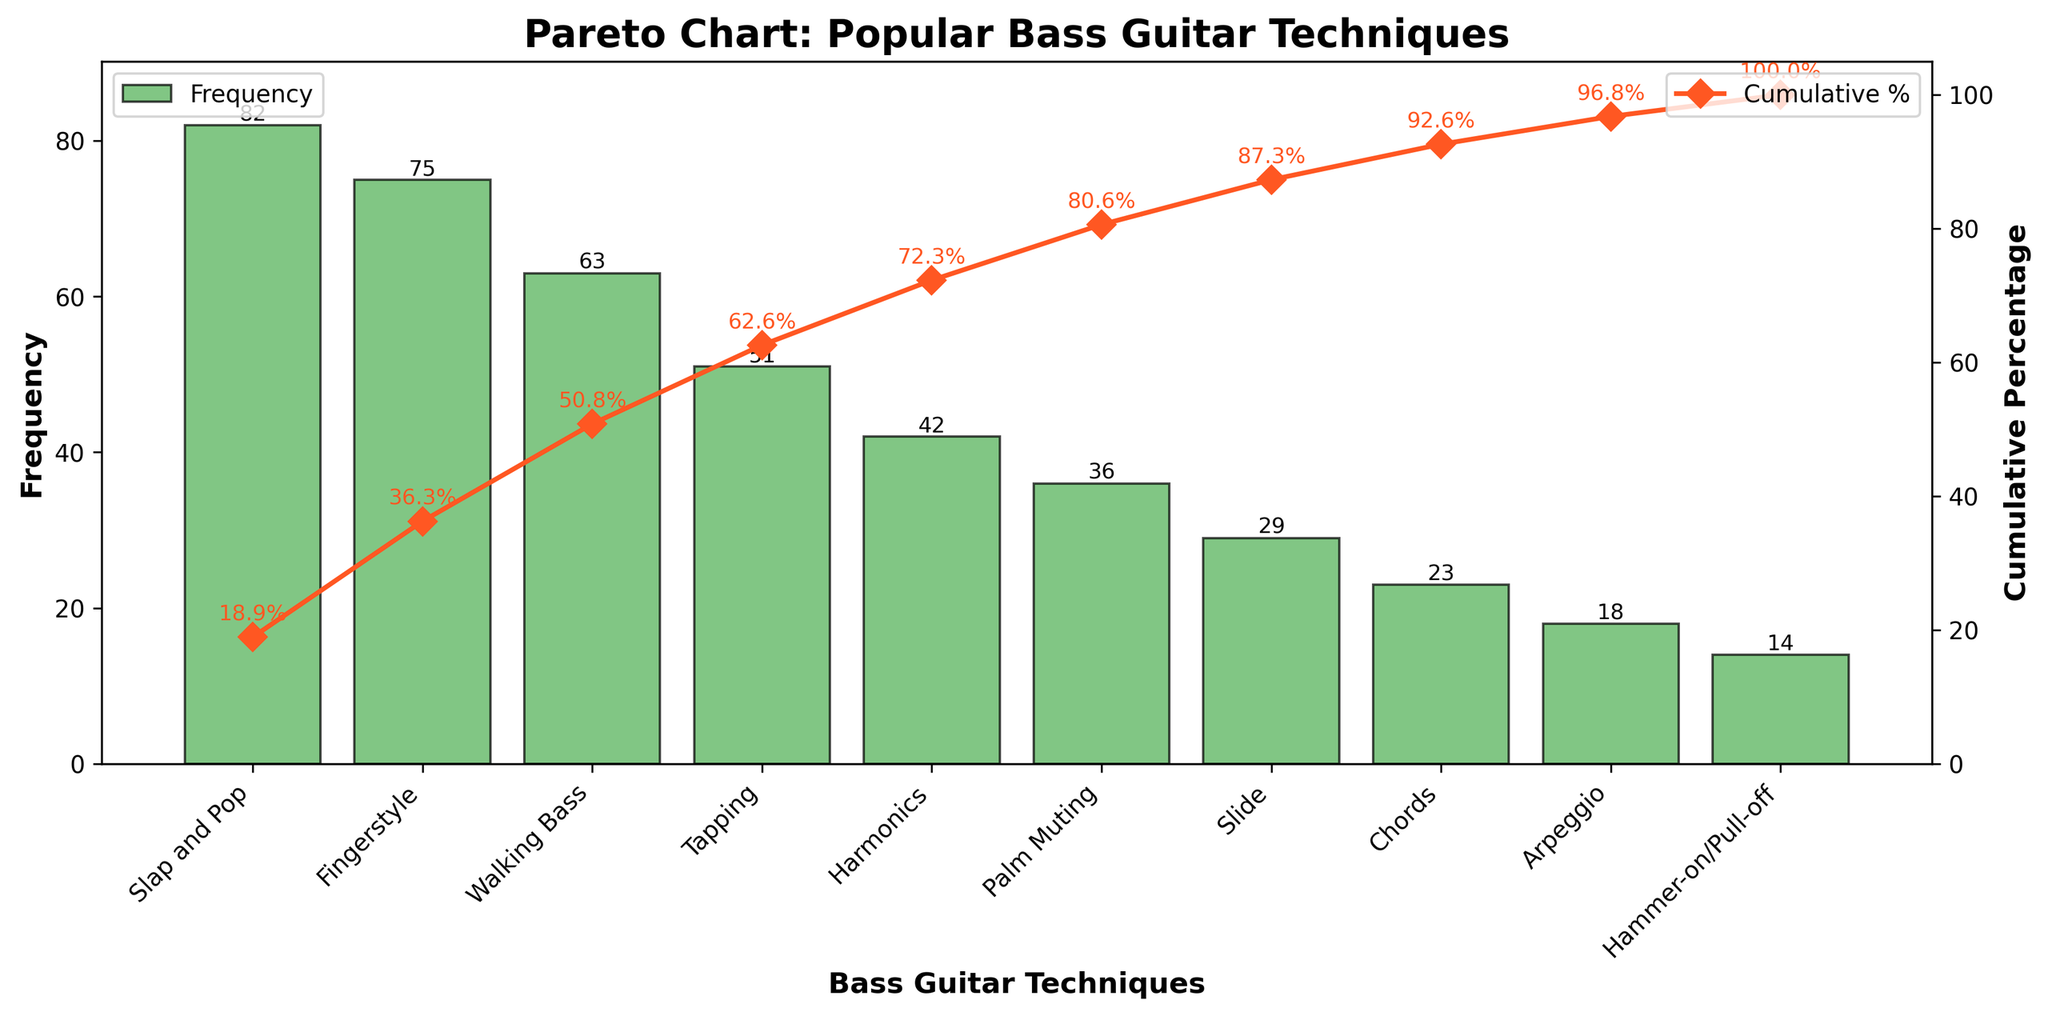How many bass guitar techniques are listed in the Pareto chart? Count the number of bars in the bar chart or the number of techniques listed on the x-axis. The figure shows bars for 10 different techniques.
Answer: 10 What is the frequency of the 'Walking Bass' technique? Look at the height of the bar corresponding to the 'Walking Bass' technique on the x-axis. The height indicates the frequency, which is annotated on top of the bar as 63.
Answer: 63 Which bass guitar technique has the lowest frequency? Identify the bar with the smallest height on the figure. The bar for 'Hammer-on/Pull-off' is the smallest and has a frequency of 14, as indicated by the text above the bar.
Answer: Hammer-on/Pull-off What is the cumulative percentage for the 'Slap and Pop' technique? Observing the cumulative percentage line chart, find the point corresponding to 'Slap and Pop' on the x-axis. The annotated value near this point shows the cumulative percentage as 22.5%.
Answer: 22.5% Which bass guitar technique is the third most popular among session musicians? Order the bars by their heights to determine the frequencies. The third-highest bar after 'Slap and Pop' and 'Fingerstyle' is 'Walking Bass' with a frequency of 63.
Answer: Walking Bass How much higher is the frequency of 'Slap and Pop' compared to 'Tapping'? Look at the heights of the bars for 'Slap and Pop' and 'Tapping'. 'Slap and Pop' has a frequency of 82, and 'Tapping' has a frequency of 51. Subtract 51 from 82 to get the difference.
Answer: 31 What percentage of the total techniques does 'Tapping' and 'Harmonics' together account for? Calculate the frequency sum of 'Tapping' (51) and 'Harmonics' (42), which is 51 + 42 = 93. Then, find the cumulative percentage at the point of 'Harmonics' which is 55.7%.
Answer: 55.7% What is the cumulative percentage after including the first five techniques? Find the point on the cumulative percentage line chart after the first five techniques ('Slap and Pop', 'Fingerstyle', 'Walking Bass', 'Tapping', and 'Harmonics'). The annotated value shows a cumulative percentage of 60.3%.
Answer: 60.3% Which technique surpasses the cumulative percentage threshold of 50%? Follow the cumulative percentage line until it crosses 50%. The annotated value for 'Harmonics' shows 55.7%, which is the point where the cumulative sum exceeds 50%.
Answer: Harmonics Is the frequency of 'Palm Muting' greater than the average frequency of all techniques? Calculate the average frequency of all techniques. Sum the frequencies (82 + 75 + 63 + 51 + 42 + 36 + 29 + 23 + 18 + 14 = 433), then divide by the number of techniques (10), which gives an average of 43.3. Compare 'Palm Muting's frequency (36) to this average.
Answer: No 